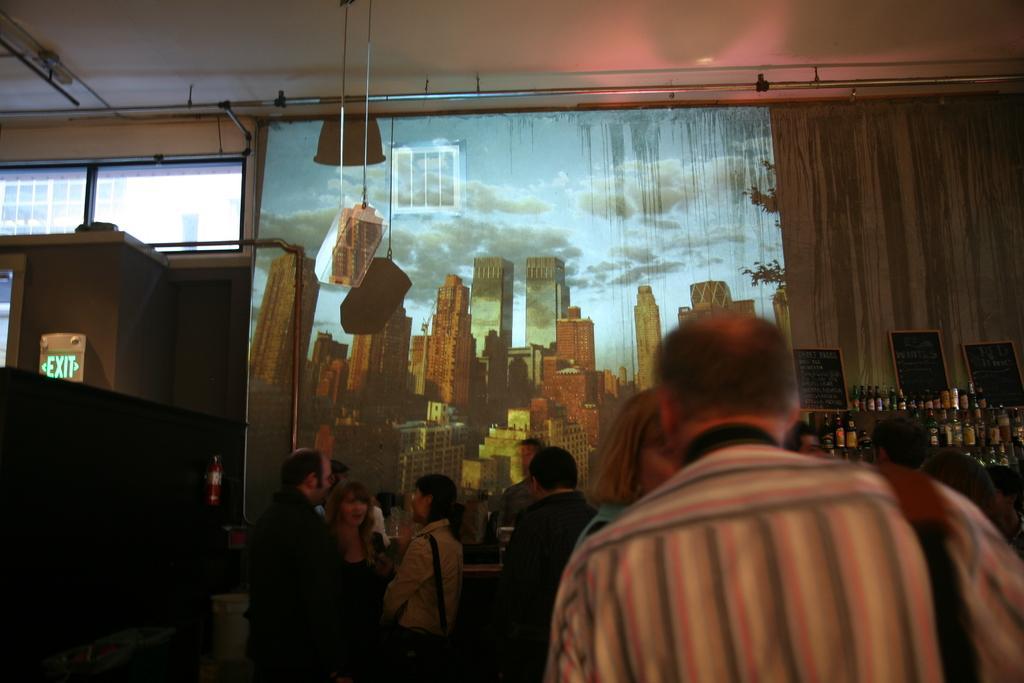Could you give a brief overview of what you see in this image? In this picture we can see a group of people, here we can see bottles, name boards, fire extinguisher and some objects. In the background we can see a screen, wall, exit board, glass doors. 